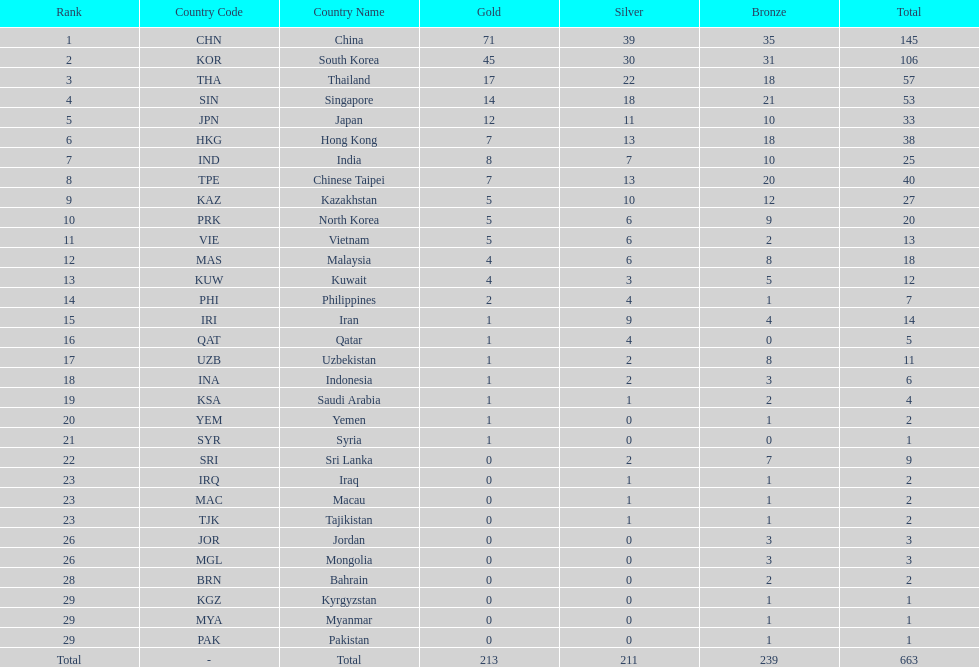Which countries have the same number of silver medals in the asian youth games as north korea? Vietnam (VIE), Malaysia (MAS). 